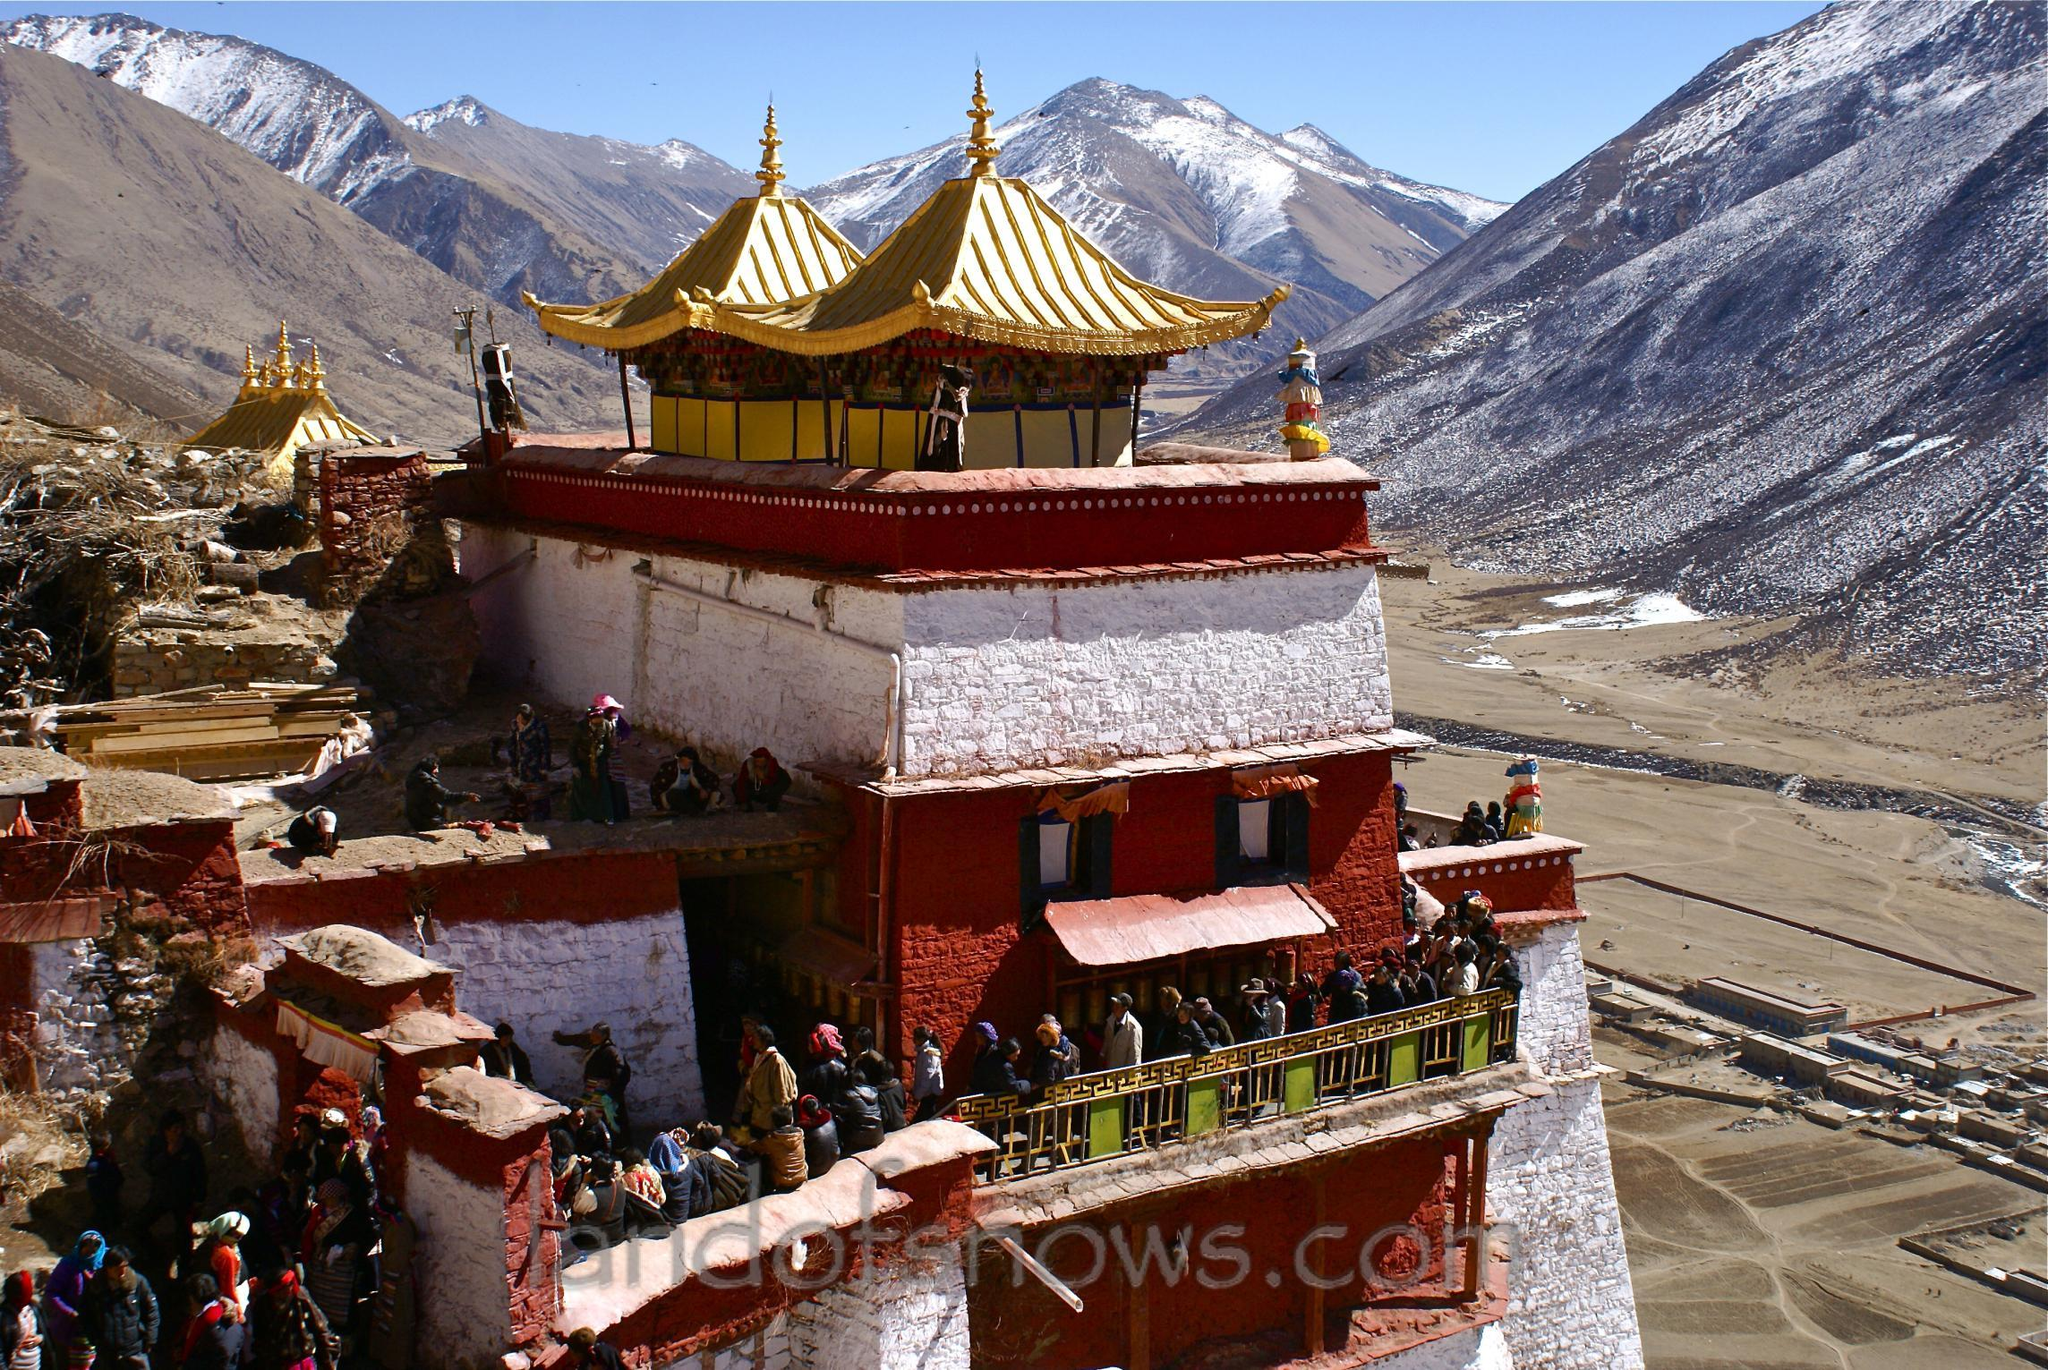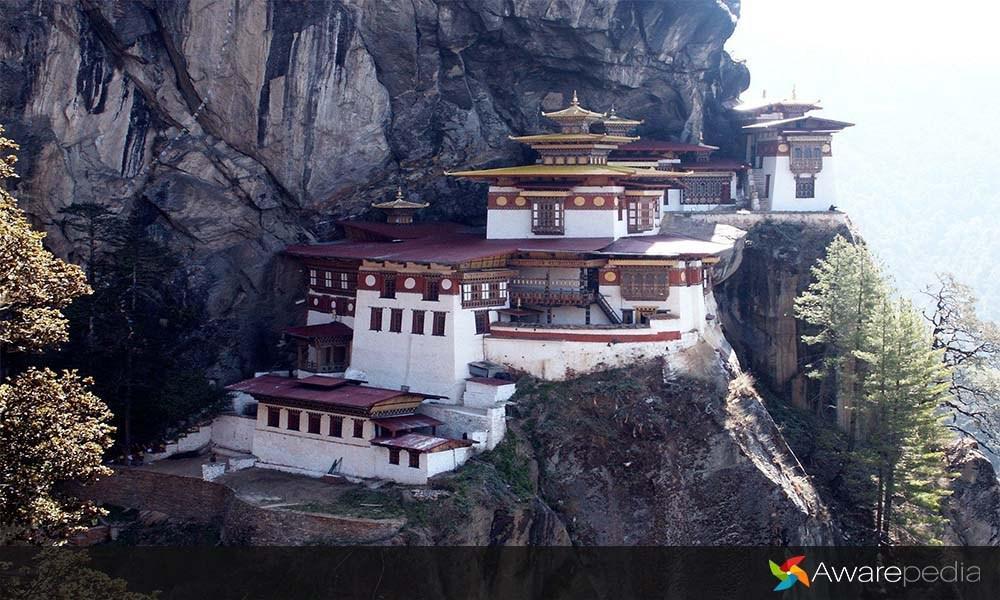The first image is the image on the left, the second image is the image on the right. Considering the images on both sides, is "An image shows a temple built in tiers that follow the shape of a side of a mountain." valid? Answer yes or no. Yes. The first image is the image on the left, the second image is the image on the right. Assess this claim about the two images: "In one of images, there is a temple built on the side of a mountain.". Correct or not? Answer yes or no. Yes. 